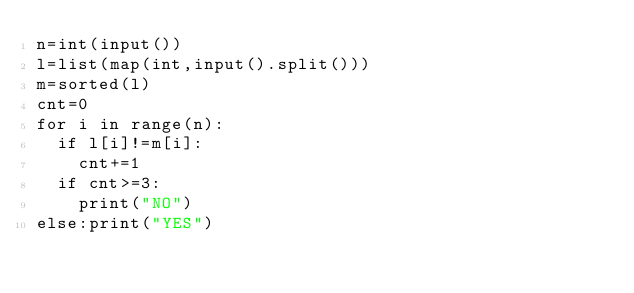Convert code to text. <code><loc_0><loc_0><loc_500><loc_500><_Python_>n=int(input())
l=list(map(int,input().split()))
m=sorted(l)
cnt=0
for i in range(n):
  if l[i]!=m[i]:
    cnt+=1
  if cnt>=3:
    print("NO")
else:print("YES")</code> 